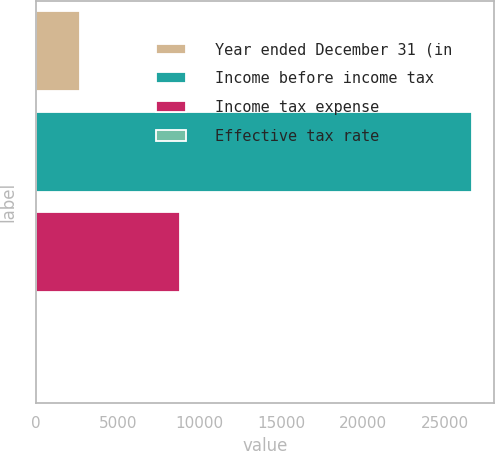Convert chart to OTSL. <chart><loc_0><loc_0><loc_500><loc_500><bar_chart><fcel>Year ended December 31 (in<fcel>Income before income tax<fcel>Income tax expense<fcel>Effective tax rate<nl><fcel>2697.11<fcel>26675<fcel>8789<fcel>32.9<nl></chart> 